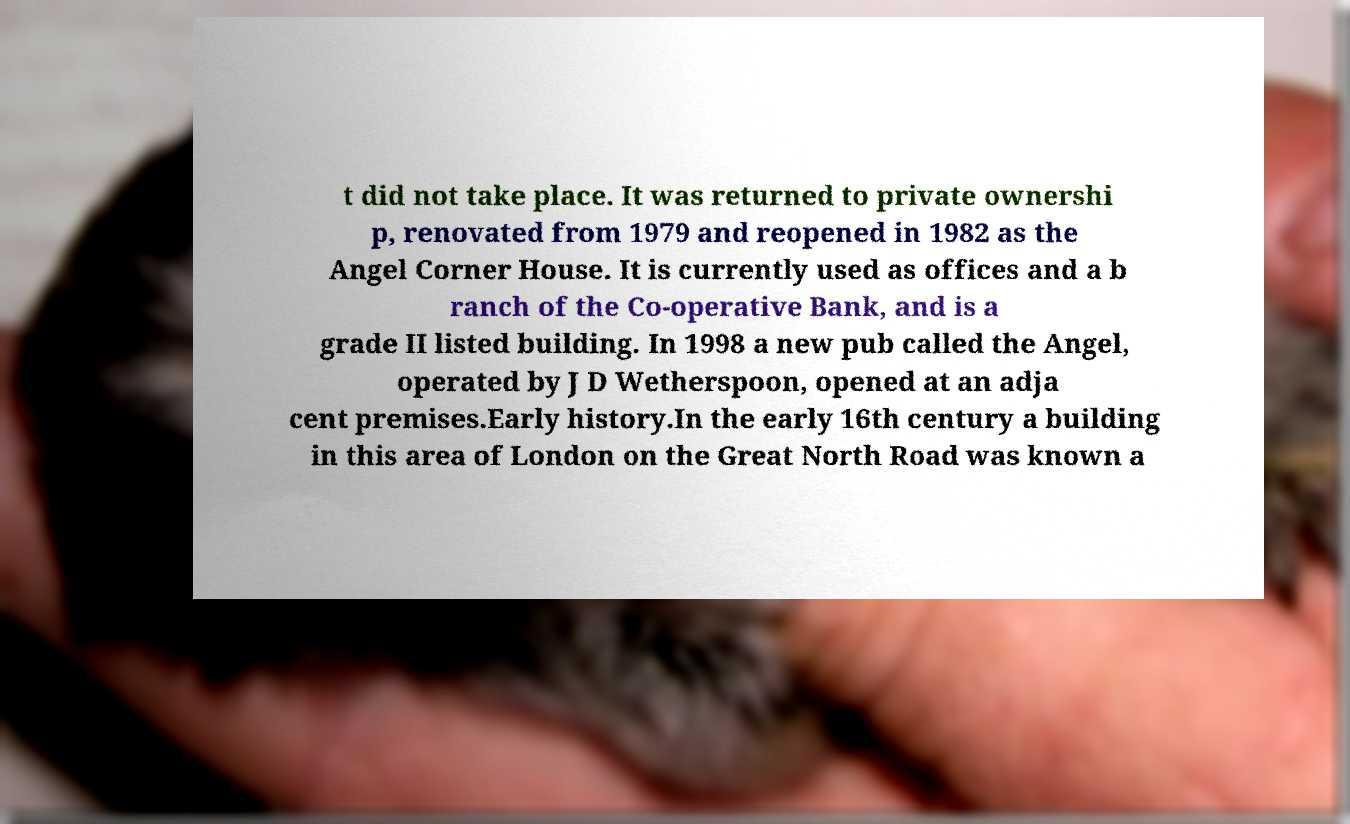What messages or text are displayed in this image? I need them in a readable, typed format. t did not take place. It was returned to private ownershi p, renovated from 1979 and reopened in 1982 as the Angel Corner House. It is currently used as offices and a b ranch of the Co-operative Bank, and is a grade II listed building. In 1998 a new pub called the Angel, operated by J D Wetherspoon, opened at an adja cent premises.Early history.In the early 16th century a building in this area of London on the Great North Road was known a 